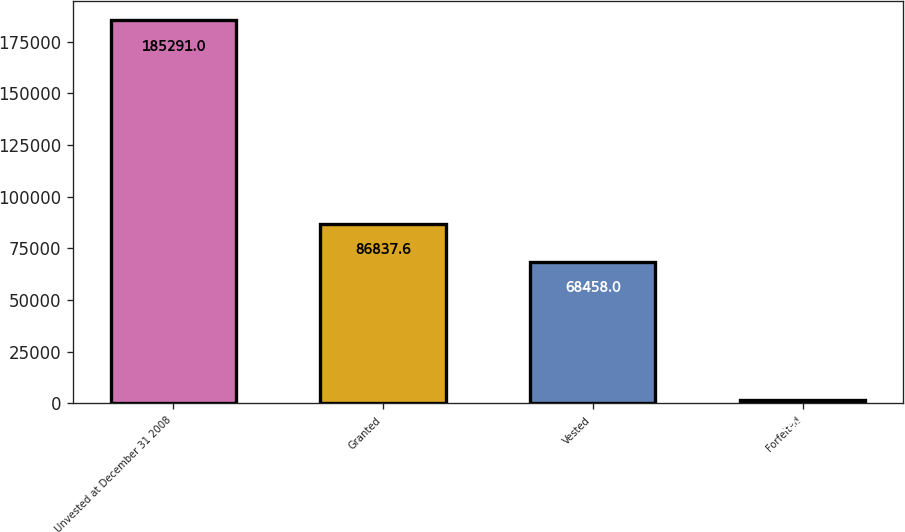Convert chart to OTSL. <chart><loc_0><loc_0><loc_500><loc_500><bar_chart><fcel>Unvested at December 31 2008<fcel>Granted<fcel>Vested<fcel>Forfeited<nl><fcel>185291<fcel>86837.6<fcel>68458<fcel>1495<nl></chart> 